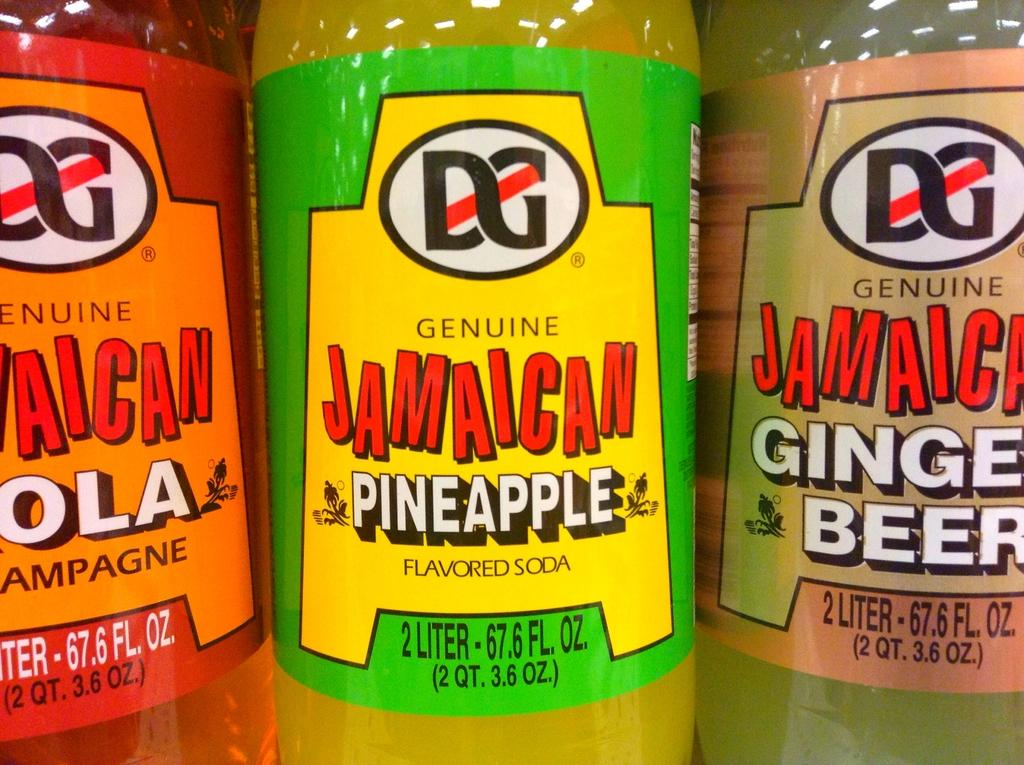<image>
Summarize the visual content of the image. Three bottles of Jamaican soda (cola, pineapple, and ginger beer flavors) stand side by side. 